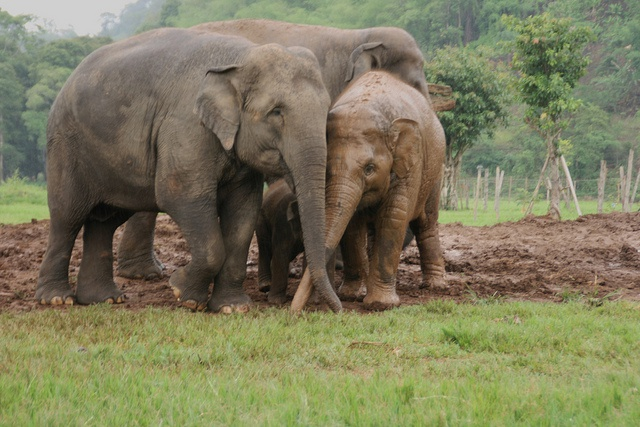Describe the objects in this image and their specific colors. I can see elephant in lightgray, gray, darkgray, and black tones, elephant in lightgray, gray, maroon, and black tones, and elephant in lightgray, darkgray, and gray tones in this image. 